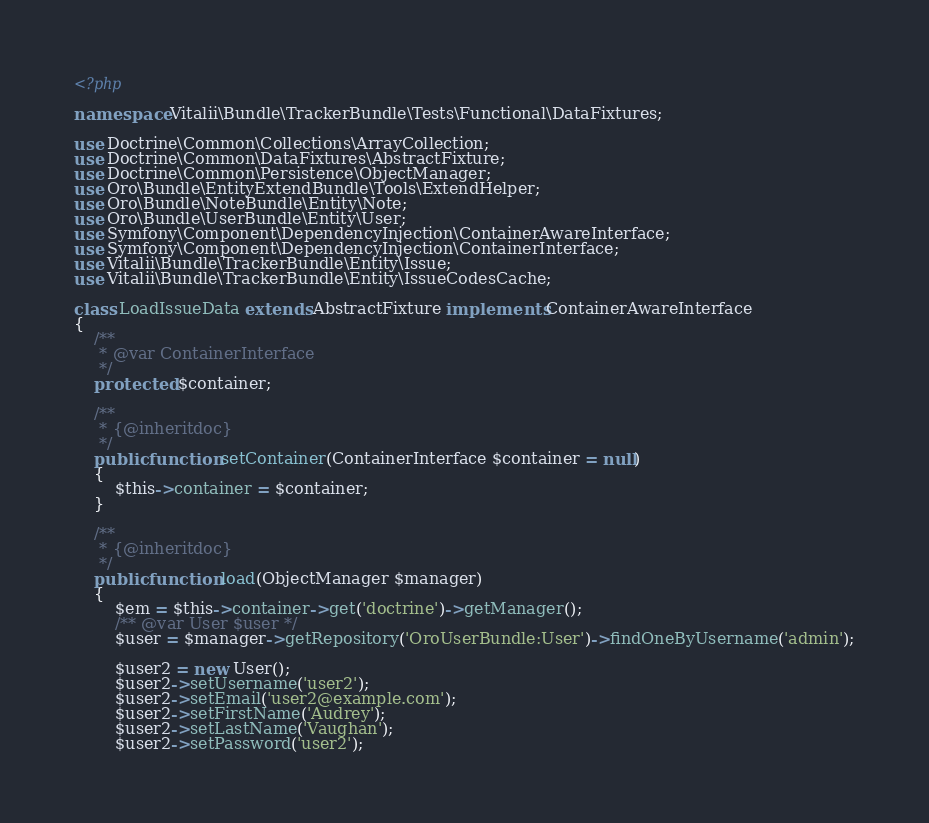Convert code to text. <code><loc_0><loc_0><loc_500><loc_500><_PHP_><?php

namespace Vitalii\Bundle\TrackerBundle\Tests\Functional\DataFixtures;

use Doctrine\Common\Collections\ArrayCollection;
use Doctrine\Common\DataFixtures\AbstractFixture;
use Doctrine\Common\Persistence\ObjectManager;
use Oro\Bundle\EntityExtendBundle\Tools\ExtendHelper;
use Oro\Bundle\NoteBundle\Entity\Note;
use Oro\Bundle\UserBundle\Entity\User;
use Symfony\Component\DependencyInjection\ContainerAwareInterface;
use Symfony\Component\DependencyInjection\ContainerInterface;
use Vitalii\Bundle\TrackerBundle\Entity\Issue;
use Vitalii\Bundle\TrackerBundle\Entity\IssueCodesCache;

class LoadIssueData extends AbstractFixture implements ContainerAwareInterface
{
    /**
     * @var ContainerInterface
     */
    protected $container;

    /**
     * {@inheritdoc}
     */
    public function setContainer(ContainerInterface $container = null)
    {
        $this->container = $container;
    }

    /**
     * {@inheritdoc}
     */
    public function load(ObjectManager $manager)
    {
        $em = $this->container->get('doctrine')->getManager();
        /** @var User $user */
        $user = $manager->getRepository('OroUserBundle:User')->findOneByUsername('admin');

        $user2 = new User();
        $user2->setUsername('user2');
        $user2->setEmail('user2@example.com');
        $user2->setFirstName('Audrey');
        $user2->setLastName('Vaughan');
        $user2->setPassword('user2');</code> 